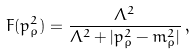<formula> <loc_0><loc_0><loc_500><loc_500>F ( p ^ { 2 } _ { \rho } ) = \frac { \Lambda ^ { 2 } } { \Lambda ^ { 2 } + | p ^ { 2 } _ { \rho } - m ^ { 2 } _ { \rho } | } \, ,</formula> 